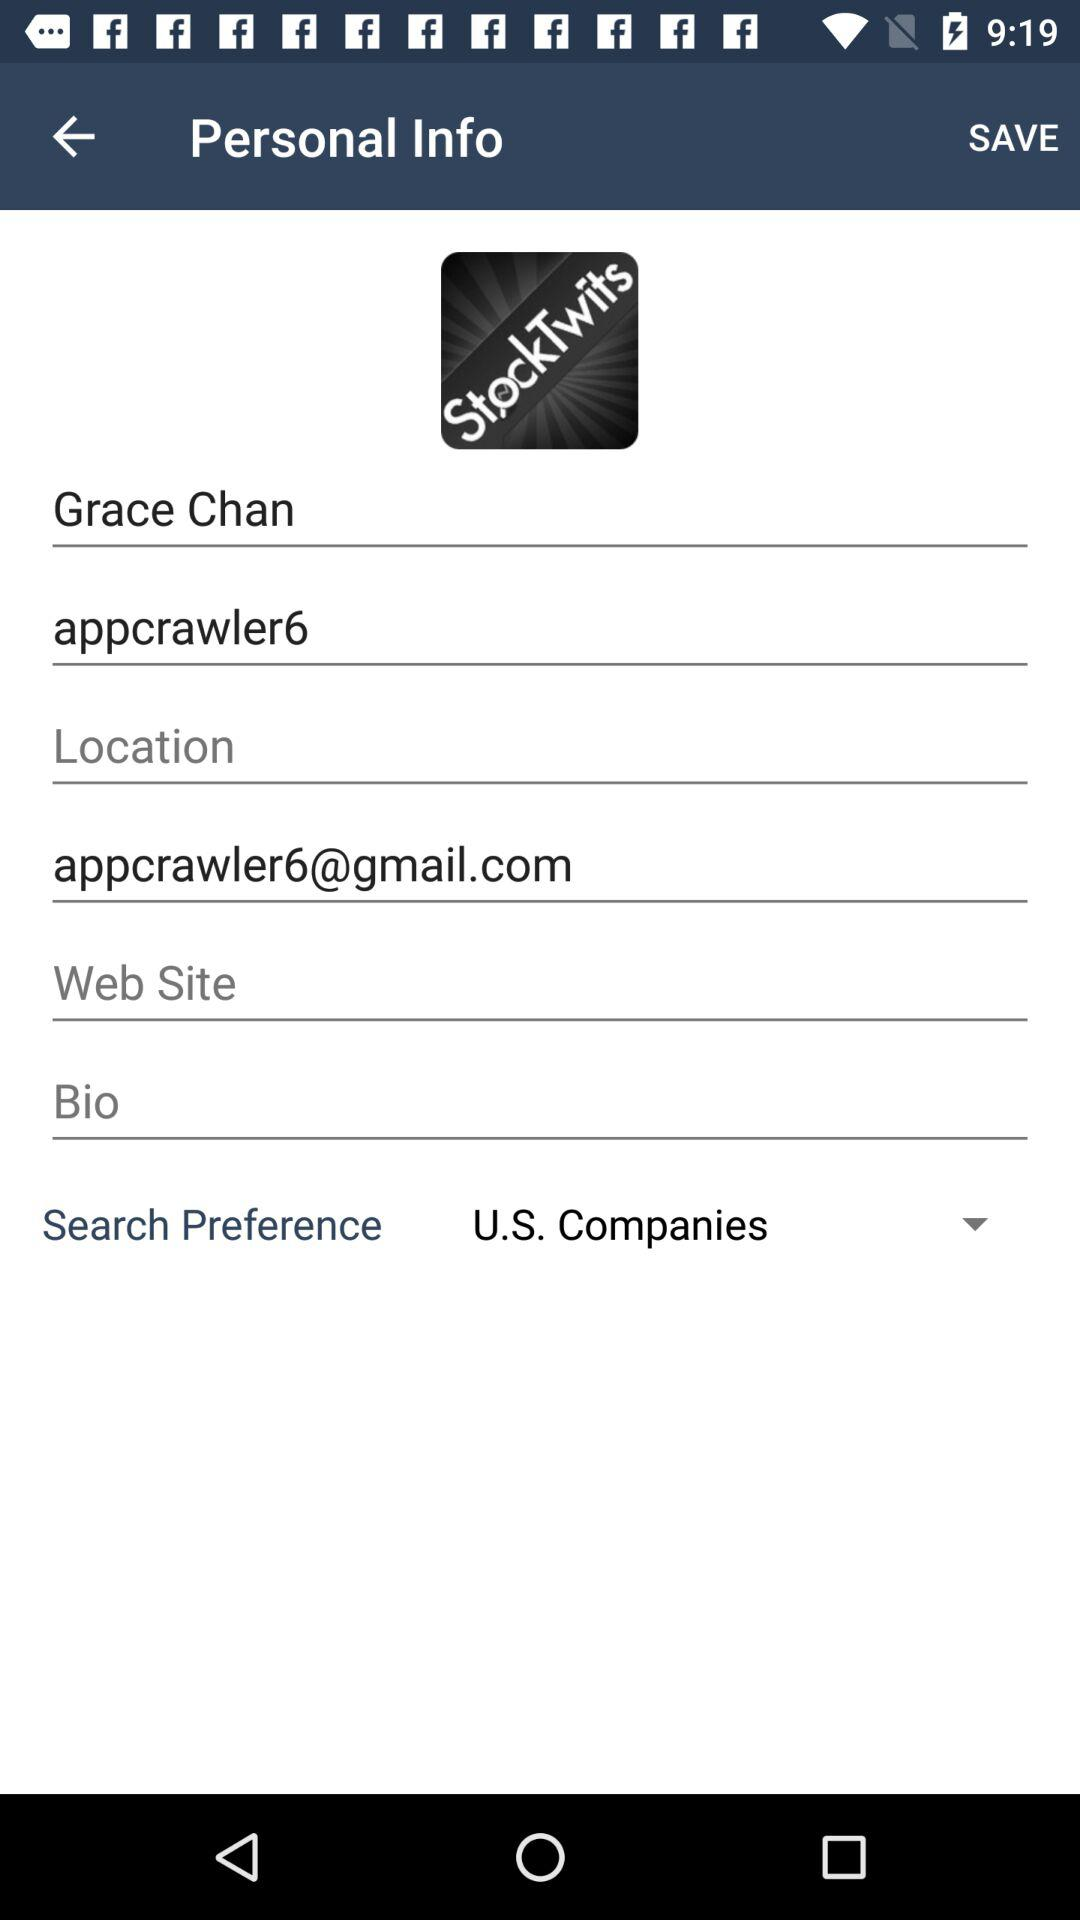What is the user name? The user name is Grace Chan. 